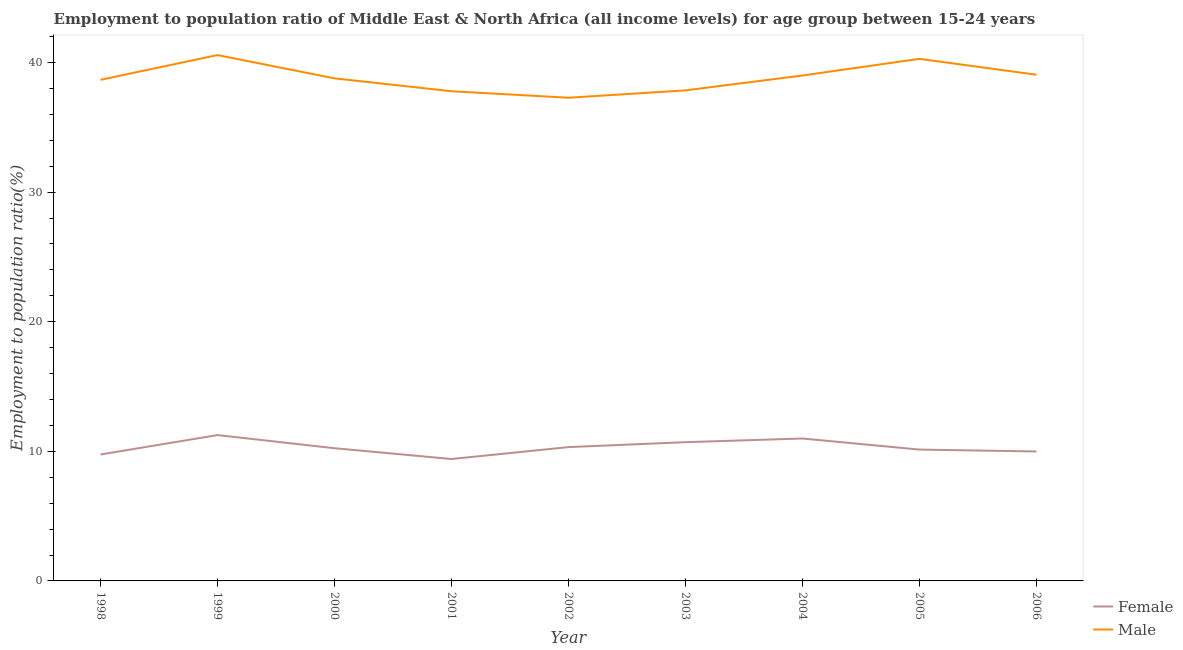How many different coloured lines are there?
Offer a very short reply. 2. Does the line corresponding to employment to population ratio(male) intersect with the line corresponding to employment to population ratio(female)?
Offer a very short reply. No. What is the employment to population ratio(male) in 2002?
Provide a succinct answer. 37.28. Across all years, what is the maximum employment to population ratio(female)?
Provide a short and direct response. 11.25. Across all years, what is the minimum employment to population ratio(female)?
Offer a very short reply. 9.41. In which year was the employment to population ratio(female) minimum?
Ensure brevity in your answer.  2001. What is the total employment to population ratio(female) in the graph?
Offer a terse response. 92.79. What is the difference between the employment to population ratio(female) in 2005 and that in 2006?
Provide a short and direct response. 0.15. What is the difference between the employment to population ratio(male) in 2001 and the employment to population ratio(female) in 2000?
Make the answer very short. 27.54. What is the average employment to population ratio(female) per year?
Provide a succinct answer. 10.31. In the year 1998, what is the difference between the employment to population ratio(female) and employment to population ratio(male)?
Give a very brief answer. -28.91. In how many years, is the employment to population ratio(male) greater than 38 %?
Offer a very short reply. 6. What is the ratio of the employment to population ratio(male) in 1999 to that in 2000?
Your answer should be compact. 1.05. Is the employment to population ratio(male) in 1999 less than that in 2003?
Keep it short and to the point. No. What is the difference between the highest and the second highest employment to population ratio(female)?
Offer a very short reply. 0.26. What is the difference between the highest and the lowest employment to population ratio(female)?
Your answer should be very brief. 1.85. In how many years, is the employment to population ratio(female) greater than the average employment to population ratio(female) taken over all years?
Provide a succinct answer. 4. Is the sum of the employment to population ratio(female) in 2001 and 2002 greater than the maximum employment to population ratio(male) across all years?
Your answer should be very brief. No. How many lines are there?
Your response must be concise. 2. How many years are there in the graph?
Give a very brief answer. 9. What is the difference between two consecutive major ticks on the Y-axis?
Provide a succinct answer. 10. Does the graph contain grids?
Your response must be concise. No. Where does the legend appear in the graph?
Ensure brevity in your answer.  Bottom right. How many legend labels are there?
Provide a short and direct response. 2. What is the title of the graph?
Your response must be concise. Employment to population ratio of Middle East & North Africa (all income levels) for age group between 15-24 years. What is the label or title of the X-axis?
Your response must be concise. Year. What is the label or title of the Y-axis?
Make the answer very short. Employment to population ratio(%). What is the Employment to population ratio(%) in Female in 1998?
Make the answer very short. 9.75. What is the Employment to population ratio(%) in Male in 1998?
Provide a short and direct response. 38.66. What is the Employment to population ratio(%) in Female in 1999?
Provide a succinct answer. 11.25. What is the Employment to population ratio(%) in Male in 1999?
Your answer should be very brief. 40.57. What is the Employment to population ratio(%) of Female in 2000?
Your answer should be compact. 10.24. What is the Employment to population ratio(%) of Male in 2000?
Keep it short and to the point. 38.78. What is the Employment to population ratio(%) of Female in 2001?
Your response must be concise. 9.41. What is the Employment to population ratio(%) in Male in 2001?
Give a very brief answer. 37.78. What is the Employment to population ratio(%) in Female in 2002?
Provide a succinct answer. 10.32. What is the Employment to population ratio(%) of Male in 2002?
Your answer should be very brief. 37.28. What is the Employment to population ratio(%) of Female in 2003?
Ensure brevity in your answer.  10.71. What is the Employment to population ratio(%) of Male in 2003?
Provide a succinct answer. 37.85. What is the Employment to population ratio(%) in Female in 2004?
Make the answer very short. 10.99. What is the Employment to population ratio(%) in Male in 2004?
Keep it short and to the point. 39. What is the Employment to population ratio(%) of Female in 2005?
Keep it short and to the point. 10.13. What is the Employment to population ratio(%) of Male in 2005?
Your answer should be compact. 40.28. What is the Employment to population ratio(%) of Female in 2006?
Your answer should be compact. 9.99. What is the Employment to population ratio(%) of Male in 2006?
Provide a short and direct response. 39.06. Across all years, what is the maximum Employment to population ratio(%) of Female?
Provide a short and direct response. 11.25. Across all years, what is the maximum Employment to population ratio(%) in Male?
Your answer should be compact. 40.57. Across all years, what is the minimum Employment to population ratio(%) of Female?
Ensure brevity in your answer.  9.41. Across all years, what is the minimum Employment to population ratio(%) of Male?
Make the answer very short. 37.28. What is the total Employment to population ratio(%) of Female in the graph?
Your answer should be compact. 92.79. What is the total Employment to population ratio(%) in Male in the graph?
Keep it short and to the point. 349.27. What is the difference between the Employment to population ratio(%) in Female in 1998 and that in 1999?
Your answer should be compact. -1.5. What is the difference between the Employment to population ratio(%) of Male in 1998 and that in 1999?
Offer a terse response. -1.91. What is the difference between the Employment to population ratio(%) of Female in 1998 and that in 2000?
Make the answer very short. -0.49. What is the difference between the Employment to population ratio(%) of Male in 1998 and that in 2000?
Provide a succinct answer. -0.11. What is the difference between the Employment to population ratio(%) in Female in 1998 and that in 2001?
Your response must be concise. 0.35. What is the difference between the Employment to population ratio(%) of Male in 1998 and that in 2001?
Your response must be concise. 0.88. What is the difference between the Employment to population ratio(%) of Female in 1998 and that in 2002?
Provide a succinct answer. -0.57. What is the difference between the Employment to population ratio(%) in Male in 1998 and that in 2002?
Give a very brief answer. 1.38. What is the difference between the Employment to population ratio(%) in Female in 1998 and that in 2003?
Provide a short and direct response. -0.95. What is the difference between the Employment to population ratio(%) of Male in 1998 and that in 2003?
Your answer should be compact. 0.81. What is the difference between the Employment to population ratio(%) in Female in 1998 and that in 2004?
Give a very brief answer. -1.23. What is the difference between the Employment to population ratio(%) of Male in 1998 and that in 2004?
Ensure brevity in your answer.  -0.33. What is the difference between the Employment to population ratio(%) of Female in 1998 and that in 2005?
Keep it short and to the point. -0.38. What is the difference between the Employment to population ratio(%) in Male in 1998 and that in 2005?
Make the answer very short. -1.62. What is the difference between the Employment to population ratio(%) of Female in 1998 and that in 2006?
Keep it short and to the point. -0.23. What is the difference between the Employment to population ratio(%) of Male in 1998 and that in 2006?
Your answer should be compact. -0.39. What is the difference between the Employment to population ratio(%) of Female in 1999 and that in 2000?
Your answer should be compact. 1.01. What is the difference between the Employment to population ratio(%) in Male in 1999 and that in 2000?
Provide a succinct answer. 1.8. What is the difference between the Employment to population ratio(%) of Female in 1999 and that in 2001?
Make the answer very short. 1.85. What is the difference between the Employment to population ratio(%) in Male in 1999 and that in 2001?
Give a very brief answer. 2.79. What is the difference between the Employment to population ratio(%) in Female in 1999 and that in 2002?
Your answer should be compact. 0.93. What is the difference between the Employment to population ratio(%) of Male in 1999 and that in 2002?
Make the answer very short. 3.29. What is the difference between the Employment to population ratio(%) of Female in 1999 and that in 2003?
Provide a succinct answer. 0.55. What is the difference between the Employment to population ratio(%) of Male in 1999 and that in 2003?
Give a very brief answer. 2.72. What is the difference between the Employment to population ratio(%) in Female in 1999 and that in 2004?
Keep it short and to the point. 0.26. What is the difference between the Employment to population ratio(%) of Male in 1999 and that in 2004?
Provide a short and direct response. 1.58. What is the difference between the Employment to population ratio(%) of Female in 1999 and that in 2005?
Ensure brevity in your answer.  1.12. What is the difference between the Employment to population ratio(%) in Male in 1999 and that in 2005?
Keep it short and to the point. 0.29. What is the difference between the Employment to population ratio(%) of Female in 1999 and that in 2006?
Provide a short and direct response. 1.26. What is the difference between the Employment to population ratio(%) in Male in 1999 and that in 2006?
Your answer should be compact. 1.52. What is the difference between the Employment to population ratio(%) of Female in 2000 and that in 2001?
Provide a short and direct response. 0.83. What is the difference between the Employment to population ratio(%) in Female in 2000 and that in 2002?
Make the answer very short. -0.08. What is the difference between the Employment to population ratio(%) of Male in 2000 and that in 2002?
Your response must be concise. 1.5. What is the difference between the Employment to population ratio(%) of Female in 2000 and that in 2003?
Give a very brief answer. -0.47. What is the difference between the Employment to population ratio(%) in Male in 2000 and that in 2003?
Your answer should be compact. 0.93. What is the difference between the Employment to population ratio(%) of Female in 2000 and that in 2004?
Ensure brevity in your answer.  -0.75. What is the difference between the Employment to population ratio(%) of Male in 2000 and that in 2004?
Give a very brief answer. -0.22. What is the difference between the Employment to population ratio(%) in Female in 2000 and that in 2005?
Provide a short and direct response. 0.11. What is the difference between the Employment to population ratio(%) of Male in 2000 and that in 2005?
Make the answer very short. -1.51. What is the difference between the Employment to population ratio(%) in Female in 2000 and that in 2006?
Make the answer very short. 0.25. What is the difference between the Employment to population ratio(%) in Male in 2000 and that in 2006?
Give a very brief answer. -0.28. What is the difference between the Employment to population ratio(%) of Female in 2001 and that in 2002?
Ensure brevity in your answer.  -0.92. What is the difference between the Employment to population ratio(%) in Male in 2001 and that in 2002?
Your response must be concise. 0.5. What is the difference between the Employment to population ratio(%) of Female in 2001 and that in 2003?
Ensure brevity in your answer.  -1.3. What is the difference between the Employment to population ratio(%) of Male in 2001 and that in 2003?
Provide a short and direct response. -0.07. What is the difference between the Employment to population ratio(%) in Female in 2001 and that in 2004?
Keep it short and to the point. -1.58. What is the difference between the Employment to population ratio(%) of Male in 2001 and that in 2004?
Your answer should be compact. -1.21. What is the difference between the Employment to population ratio(%) of Female in 2001 and that in 2005?
Keep it short and to the point. -0.73. What is the difference between the Employment to population ratio(%) of Male in 2001 and that in 2005?
Give a very brief answer. -2.5. What is the difference between the Employment to population ratio(%) of Female in 2001 and that in 2006?
Keep it short and to the point. -0.58. What is the difference between the Employment to population ratio(%) in Male in 2001 and that in 2006?
Offer a very short reply. -1.27. What is the difference between the Employment to population ratio(%) of Female in 2002 and that in 2003?
Offer a terse response. -0.38. What is the difference between the Employment to population ratio(%) in Male in 2002 and that in 2003?
Ensure brevity in your answer.  -0.57. What is the difference between the Employment to population ratio(%) in Female in 2002 and that in 2004?
Provide a succinct answer. -0.66. What is the difference between the Employment to population ratio(%) of Male in 2002 and that in 2004?
Provide a succinct answer. -1.72. What is the difference between the Employment to population ratio(%) in Female in 2002 and that in 2005?
Keep it short and to the point. 0.19. What is the difference between the Employment to population ratio(%) of Male in 2002 and that in 2005?
Offer a very short reply. -3. What is the difference between the Employment to population ratio(%) of Female in 2002 and that in 2006?
Your answer should be very brief. 0.34. What is the difference between the Employment to population ratio(%) in Male in 2002 and that in 2006?
Your answer should be very brief. -1.78. What is the difference between the Employment to population ratio(%) of Female in 2003 and that in 2004?
Offer a very short reply. -0.28. What is the difference between the Employment to population ratio(%) in Male in 2003 and that in 2004?
Make the answer very short. -1.15. What is the difference between the Employment to population ratio(%) of Female in 2003 and that in 2005?
Your answer should be compact. 0.57. What is the difference between the Employment to population ratio(%) in Male in 2003 and that in 2005?
Your answer should be very brief. -2.43. What is the difference between the Employment to population ratio(%) of Female in 2003 and that in 2006?
Provide a succinct answer. 0.72. What is the difference between the Employment to population ratio(%) in Male in 2003 and that in 2006?
Your answer should be very brief. -1.21. What is the difference between the Employment to population ratio(%) of Female in 2004 and that in 2005?
Your answer should be very brief. 0.86. What is the difference between the Employment to population ratio(%) in Male in 2004 and that in 2005?
Your answer should be compact. -1.29. What is the difference between the Employment to population ratio(%) in Male in 2004 and that in 2006?
Offer a very short reply. -0.06. What is the difference between the Employment to population ratio(%) in Female in 2005 and that in 2006?
Give a very brief answer. 0.15. What is the difference between the Employment to population ratio(%) of Male in 2005 and that in 2006?
Ensure brevity in your answer.  1.23. What is the difference between the Employment to population ratio(%) of Female in 1998 and the Employment to population ratio(%) of Male in 1999?
Give a very brief answer. -30.82. What is the difference between the Employment to population ratio(%) of Female in 1998 and the Employment to population ratio(%) of Male in 2000?
Keep it short and to the point. -29.02. What is the difference between the Employment to population ratio(%) of Female in 1998 and the Employment to population ratio(%) of Male in 2001?
Your response must be concise. -28.03. What is the difference between the Employment to population ratio(%) of Female in 1998 and the Employment to population ratio(%) of Male in 2002?
Make the answer very short. -27.53. What is the difference between the Employment to population ratio(%) in Female in 1998 and the Employment to population ratio(%) in Male in 2003?
Your answer should be compact. -28.1. What is the difference between the Employment to population ratio(%) in Female in 1998 and the Employment to population ratio(%) in Male in 2004?
Make the answer very short. -29.24. What is the difference between the Employment to population ratio(%) in Female in 1998 and the Employment to population ratio(%) in Male in 2005?
Provide a succinct answer. -30.53. What is the difference between the Employment to population ratio(%) in Female in 1998 and the Employment to population ratio(%) in Male in 2006?
Make the answer very short. -29.3. What is the difference between the Employment to population ratio(%) of Female in 1999 and the Employment to population ratio(%) of Male in 2000?
Provide a short and direct response. -27.53. What is the difference between the Employment to population ratio(%) of Female in 1999 and the Employment to population ratio(%) of Male in 2001?
Provide a succinct answer. -26.53. What is the difference between the Employment to population ratio(%) of Female in 1999 and the Employment to population ratio(%) of Male in 2002?
Keep it short and to the point. -26.03. What is the difference between the Employment to population ratio(%) in Female in 1999 and the Employment to population ratio(%) in Male in 2003?
Ensure brevity in your answer.  -26.6. What is the difference between the Employment to population ratio(%) of Female in 1999 and the Employment to population ratio(%) of Male in 2004?
Keep it short and to the point. -27.75. What is the difference between the Employment to population ratio(%) in Female in 1999 and the Employment to population ratio(%) in Male in 2005?
Your answer should be compact. -29.03. What is the difference between the Employment to population ratio(%) of Female in 1999 and the Employment to population ratio(%) of Male in 2006?
Your answer should be very brief. -27.81. What is the difference between the Employment to population ratio(%) in Female in 2000 and the Employment to population ratio(%) in Male in 2001?
Your answer should be very brief. -27.54. What is the difference between the Employment to population ratio(%) of Female in 2000 and the Employment to population ratio(%) of Male in 2002?
Give a very brief answer. -27.04. What is the difference between the Employment to population ratio(%) in Female in 2000 and the Employment to population ratio(%) in Male in 2003?
Your answer should be compact. -27.61. What is the difference between the Employment to population ratio(%) of Female in 2000 and the Employment to population ratio(%) of Male in 2004?
Offer a terse response. -28.76. What is the difference between the Employment to population ratio(%) in Female in 2000 and the Employment to population ratio(%) in Male in 2005?
Keep it short and to the point. -30.04. What is the difference between the Employment to population ratio(%) of Female in 2000 and the Employment to population ratio(%) of Male in 2006?
Your answer should be very brief. -28.82. What is the difference between the Employment to population ratio(%) of Female in 2001 and the Employment to population ratio(%) of Male in 2002?
Keep it short and to the point. -27.88. What is the difference between the Employment to population ratio(%) of Female in 2001 and the Employment to population ratio(%) of Male in 2003?
Provide a succinct answer. -28.44. What is the difference between the Employment to population ratio(%) of Female in 2001 and the Employment to population ratio(%) of Male in 2004?
Your answer should be compact. -29.59. What is the difference between the Employment to population ratio(%) in Female in 2001 and the Employment to population ratio(%) in Male in 2005?
Give a very brief answer. -30.88. What is the difference between the Employment to population ratio(%) in Female in 2001 and the Employment to population ratio(%) in Male in 2006?
Provide a short and direct response. -29.65. What is the difference between the Employment to population ratio(%) of Female in 2002 and the Employment to population ratio(%) of Male in 2003?
Your answer should be very brief. -27.53. What is the difference between the Employment to population ratio(%) of Female in 2002 and the Employment to population ratio(%) of Male in 2004?
Keep it short and to the point. -28.67. What is the difference between the Employment to population ratio(%) in Female in 2002 and the Employment to population ratio(%) in Male in 2005?
Make the answer very short. -29.96. What is the difference between the Employment to population ratio(%) of Female in 2002 and the Employment to population ratio(%) of Male in 2006?
Give a very brief answer. -28.73. What is the difference between the Employment to population ratio(%) of Female in 2003 and the Employment to population ratio(%) of Male in 2004?
Offer a very short reply. -28.29. What is the difference between the Employment to population ratio(%) in Female in 2003 and the Employment to population ratio(%) in Male in 2005?
Keep it short and to the point. -29.58. What is the difference between the Employment to population ratio(%) in Female in 2003 and the Employment to population ratio(%) in Male in 2006?
Offer a terse response. -28.35. What is the difference between the Employment to population ratio(%) in Female in 2004 and the Employment to population ratio(%) in Male in 2005?
Provide a short and direct response. -29.29. What is the difference between the Employment to population ratio(%) in Female in 2004 and the Employment to population ratio(%) in Male in 2006?
Give a very brief answer. -28.07. What is the difference between the Employment to population ratio(%) of Female in 2005 and the Employment to population ratio(%) of Male in 2006?
Make the answer very short. -28.92. What is the average Employment to population ratio(%) in Female per year?
Your response must be concise. 10.31. What is the average Employment to population ratio(%) of Male per year?
Offer a very short reply. 38.81. In the year 1998, what is the difference between the Employment to population ratio(%) of Female and Employment to population ratio(%) of Male?
Ensure brevity in your answer.  -28.91. In the year 1999, what is the difference between the Employment to population ratio(%) of Female and Employment to population ratio(%) of Male?
Provide a short and direct response. -29.32. In the year 2000, what is the difference between the Employment to population ratio(%) of Female and Employment to population ratio(%) of Male?
Provide a succinct answer. -28.54. In the year 2001, what is the difference between the Employment to population ratio(%) of Female and Employment to population ratio(%) of Male?
Your response must be concise. -28.38. In the year 2002, what is the difference between the Employment to population ratio(%) of Female and Employment to population ratio(%) of Male?
Keep it short and to the point. -26.96. In the year 2003, what is the difference between the Employment to population ratio(%) of Female and Employment to population ratio(%) of Male?
Ensure brevity in your answer.  -27.14. In the year 2004, what is the difference between the Employment to population ratio(%) of Female and Employment to population ratio(%) of Male?
Your answer should be compact. -28.01. In the year 2005, what is the difference between the Employment to population ratio(%) in Female and Employment to population ratio(%) in Male?
Your response must be concise. -30.15. In the year 2006, what is the difference between the Employment to population ratio(%) in Female and Employment to population ratio(%) in Male?
Provide a succinct answer. -29.07. What is the ratio of the Employment to population ratio(%) of Female in 1998 to that in 1999?
Make the answer very short. 0.87. What is the ratio of the Employment to population ratio(%) of Male in 1998 to that in 1999?
Give a very brief answer. 0.95. What is the ratio of the Employment to population ratio(%) of Female in 1998 to that in 2000?
Your answer should be compact. 0.95. What is the ratio of the Employment to population ratio(%) of Male in 1998 to that in 2001?
Provide a succinct answer. 1.02. What is the ratio of the Employment to population ratio(%) in Female in 1998 to that in 2002?
Provide a short and direct response. 0.94. What is the ratio of the Employment to population ratio(%) in Male in 1998 to that in 2002?
Your response must be concise. 1.04. What is the ratio of the Employment to population ratio(%) in Female in 1998 to that in 2003?
Your answer should be compact. 0.91. What is the ratio of the Employment to population ratio(%) in Male in 1998 to that in 2003?
Keep it short and to the point. 1.02. What is the ratio of the Employment to population ratio(%) in Female in 1998 to that in 2004?
Your response must be concise. 0.89. What is the ratio of the Employment to population ratio(%) of Female in 1998 to that in 2005?
Offer a terse response. 0.96. What is the ratio of the Employment to population ratio(%) in Male in 1998 to that in 2005?
Your response must be concise. 0.96. What is the ratio of the Employment to population ratio(%) in Female in 1998 to that in 2006?
Make the answer very short. 0.98. What is the ratio of the Employment to population ratio(%) in Female in 1999 to that in 2000?
Keep it short and to the point. 1.1. What is the ratio of the Employment to population ratio(%) in Male in 1999 to that in 2000?
Your response must be concise. 1.05. What is the ratio of the Employment to population ratio(%) in Female in 1999 to that in 2001?
Give a very brief answer. 1.2. What is the ratio of the Employment to population ratio(%) in Male in 1999 to that in 2001?
Your answer should be compact. 1.07. What is the ratio of the Employment to population ratio(%) of Female in 1999 to that in 2002?
Provide a short and direct response. 1.09. What is the ratio of the Employment to population ratio(%) in Male in 1999 to that in 2002?
Give a very brief answer. 1.09. What is the ratio of the Employment to population ratio(%) in Female in 1999 to that in 2003?
Ensure brevity in your answer.  1.05. What is the ratio of the Employment to population ratio(%) in Male in 1999 to that in 2003?
Provide a succinct answer. 1.07. What is the ratio of the Employment to population ratio(%) of Female in 1999 to that in 2004?
Your answer should be compact. 1.02. What is the ratio of the Employment to population ratio(%) of Male in 1999 to that in 2004?
Offer a terse response. 1.04. What is the ratio of the Employment to population ratio(%) in Female in 1999 to that in 2005?
Your response must be concise. 1.11. What is the ratio of the Employment to population ratio(%) in Male in 1999 to that in 2005?
Offer a very short reply. 1.01. What is the ratio of the Employment to population ratio(%) in Female in 1999 to that in 2006?
Make the answer very short. 1.13. What is the ratio of the Employment to population ratio(%) in Male in 1999 to that in 2006?
Provide a short and direct response. 1.04. What is the ratio of the Employment to population ratio(%) in Female in 2000 to that in 2001?
Keep it short and to the point. 1.09. What is the ratio of the Employment to population ratio(%) in Male in 2000 to that in 2001?
Ensure brevity in your answer.  1.03. What is the ratio of the Employment to population ratio(%) in Female in 2000 to that in 2002?
Give a very brief answer. 0.99. What is the ratio of the Employment to population ratio(%) in Male in 2000 to that in 2002?
Offer a very short reply. 1.04. What is the ratio of the Employment to population ratio(%) in Female in 2000 to that in 2003?
Provide a short and direct response. 0.96. What is the ratio of the Employment to population ratio(%) in Male in 2000 to that in 2003?
Offer a terse response. 1.02. What is the ratio of the Employment to population ratio(%) in Female in 2000 to that in 2004?
Your response must be concise. 0.93. What is the ratio of the Employment to population ratio(%) in Male in 2000 to that in 2004?
Provide a succinct answer. 0.99. What is the ratio of the Employment to population ratio(%) of Female in 2000 to that in 2005?
Make the answer very short. 1.01. What is the ratio of the Employment to population ratio(%) in Male in 2000 to that in 2005?
Your response must be concise. 0.96. What is the ratio of the Employment to population ratio(%) in Female in 2000 to that in 2006?
Provide a short and direct response. 1.03. What is the ratio of the Employment to population ratio(%) of Male in 2000 to that in 2006?
Your answer should be compact. 0.99. What is the ratio of the Employment to population ratio(%) of Female in 2001 to that in 2002?
Your answer should be very brief. 0.91. What is the ratio of the Employment to population ratio(%) in Male in 2001 to that in 2002?
Offer a very short reply. 1.01. What is the ratio of the Employment to population ratio(%) of Female in 2001 to that in 2003?
Your answer should be compact. 0.88. What is the ratio of the Employment to population ratio(%) in Female in 2001 to that in 2004?
Provide a succinct answer. 0.86. What is the ratio of the Employment to population ratio(%) of Male in 2001 to that in 2004?
Ensure brevity in your answer.  0.97. What is the ratio of the Employment to population ratio(%) of Female in 2001 to that in 2005?
Provide a succinct answer. 0.93. What is the ratio of the Employment to population ratio(%) of Male in 2001 to that in 2005?
Offer a terse response. 0.94. What is the ratio of the Employment to population ratio(%) in Female in 2001 to that in 2006?
Give a very brief answer. 0.94. What is the ratio of the Employment to population ratio(%) in Male in 2001 to that in 2006?
Your answer should be very brief. 0.97. What is the ratio of the Employment to population ratio(%) in Female in 2002 to that in 2003?
Your answer should be compact. 0.96. What is the ratio of the Employment to population ratio(%) in Female in 2002 to that in 2004?
Your answer should be very brief. 0.94. What is the ratio of the Employment to population ratio(%) of Male in 2002 to that in 2004?
Ensure brevity in your answer.  0.96. What is the ratio of the Employment to population ratio(%) in Female in 2002 to that in 2005?
Your response must be concise. 1.02. What is the ratio of the Employment to population ratio(%) in Male in 2002 to that in 2005?
Your answer should be compact. 0.93. What is the ratio of the Employment to population ratio(%) in Female in 2002 to that in 2006?
Ensure brevity in your answer.  1.03. What is the ratio of the Employment to population ratio(%) of Male in 2002 to that in 2006?
Your answer should be very brief. 0.95. What is the ratio of the Employment to population ratio(%) in Female in 2003 to that in 2004?
Give a very brief answer. 0.97. What is the ratio of the Employment to population ratio(%) in Male in 2003 to that in 2004?
Offer a terse response. 0.97. What is the ratio of the Employment to population ratio(%) in Female in 2003 to that in 2005?
Provide a short and direct response. 1.06. What is the ratio of the Employment to population ratio(%) in Male in 2003 to that in 2005?
Your answer should be very brief. 0.94. What is the ratio of the Employment to population ratio(%) in Female in 2003 to that in 2006?
Your response must be concise. 1.07. What is the ratio of the Employment to population ratio(%) of Male in 2003 to that in 2006?
Your answer should be compact. 0.97. What is the ratio of the Employment to population ratio(%) of Female in 2004 to that in 2005?
Your answer should be very brief. 1.08. What is the ratio of the Employment to population ratio(%) in Male in 2004 to that in 2005?
Keep it short and to the point. 0.97. What is the ratio of the Employment to population ratio(%) of Female in 2004 to that in 2006?
Your answer should be compact. 1.1. What is the ratio of the Employment to population ratio(%) in Male in 2004 to that in 2006?
Your answer should be very brief. 1. What is the ratio of the Employment to population ratio(%) of Female in 2005 to that in 2006?
Provide a succinct answer. 1.01. What is the ratio of the Employment to population ratio(%) in Male in 2005 to that in 2006?
Provide a succinct answer. 1.03. What is the difference between the highest and the second highest Employment to population ratio(%) of Female?
Your response must be concise. 0.26. What is the difference between the highest and the second highest Employment to population ratio(%) of Male?
Make the answer very short. 0.29. What is the difference between the highest and the lowest Employment to population ratio(%) in Female?
Offer a terse response. 1.85. What is the difference between the highest and the lowest Employment to population ratio(%) in Male?
Provide a succinct answer. 3.29. 